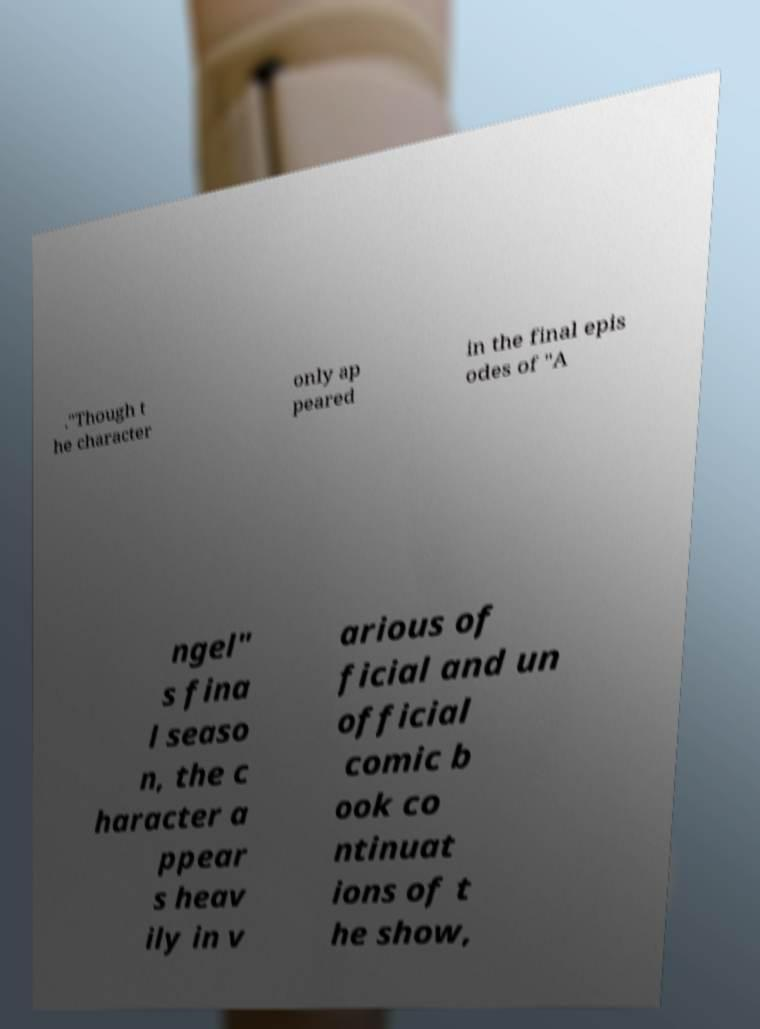Please identify and transcribe the text found in this image. ."Though t he character only ap peared in the final epis odes of "A ngel" s fina l seaso n, the c haracter a ppear s heav ily in v arious of ficial and un official comic b ook co ntinuat ions of t he show, 